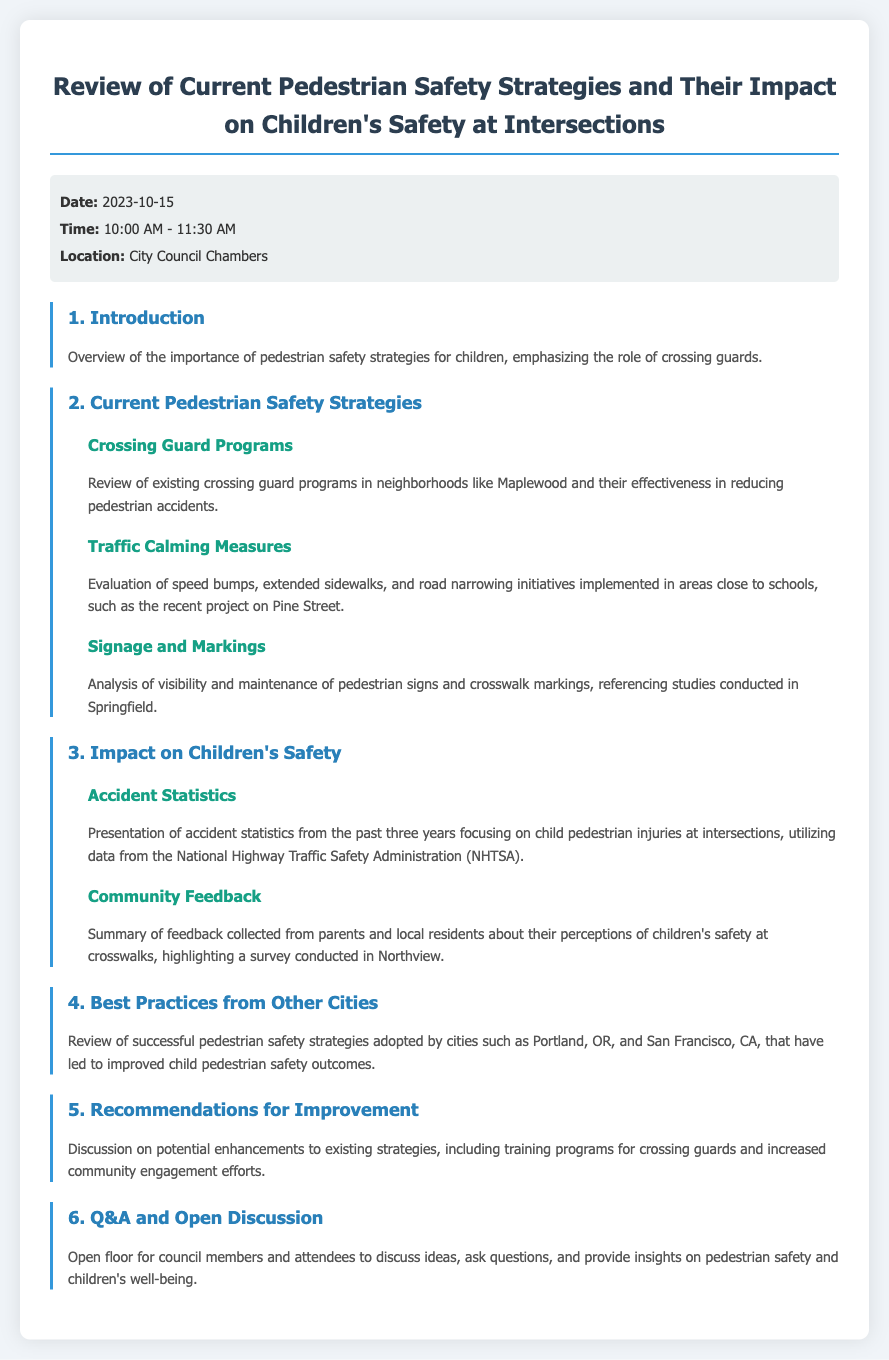What is the date of the meeting? The date of the meeting is stated in the meta-info section of the document.
Answer: 2023-10-15 What is the time duration of the meeting? The time listed in the meta-info indicates the starting and ending time of the meeting.
Answer: 10:00 AM - 11:30 AM Which neighborhoods are mentioned in the review of crossing guard programs? The document specifically mentions neighborhoods related to the effectiveness of crossing guard programs.
Answer: Maplewood What traffic calming measure is referenced near schools? The document discusses specific traffic calming measures that have been implemented in school areas.
Answer: speed bumps What data source is used for accident statistics? The document specifies the organization that provided the statistics about child pedestrian injuries.
Answer: National Highway Traffic Safety Administration (NHTSA) What is one of the key topics discussed under community feedback? The summary of community feedback highlights parents' perceptions regarding specific safety features.
Answer: children's safety at crosswalks Which cities' pedestrian safety strategies are reviewed for best practices? The document cites cities known for their successful pedestrian safety strategies.
Answer: Portland, OR, and San Francisco, CA What recommendations are suggested for crossing guards? The document mentions potential improvements related to training.
Answer: training programs for crossing guards 